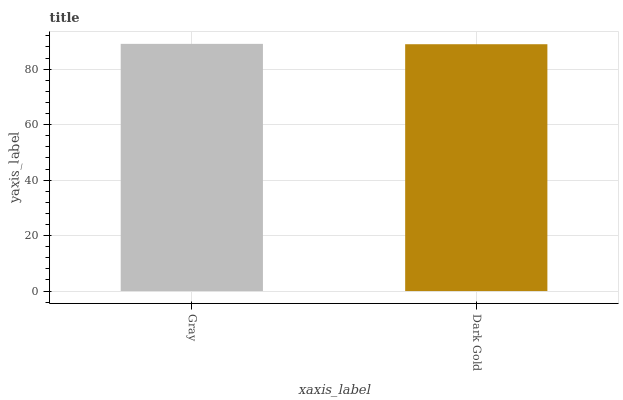Is Dark Gold the minimum?
Answer yes or no. Yes. Is Gray the maximum?
Answer yes or no. Yes. Is Dark Gold the maximum?
Answer yes or no. No. Is Gray greater than Dark Gold?
Answer yes or no. Yes. Is Dark Gold less than Gray?
Answer yes or no. Yes. Is Dark Gold greater than Gray?
Answer yes or no. No. Is Gray less than Dark Gold?
Answer yes or no. No. Is Gray the high median?
Answer yes or no. Yes. Is Dark Gold the low median?
Answer yes or no. Yes. Is Dark Gold the high median?
Answer yes or no. No. Is Gray the low median?
Answer yes or no. No. 